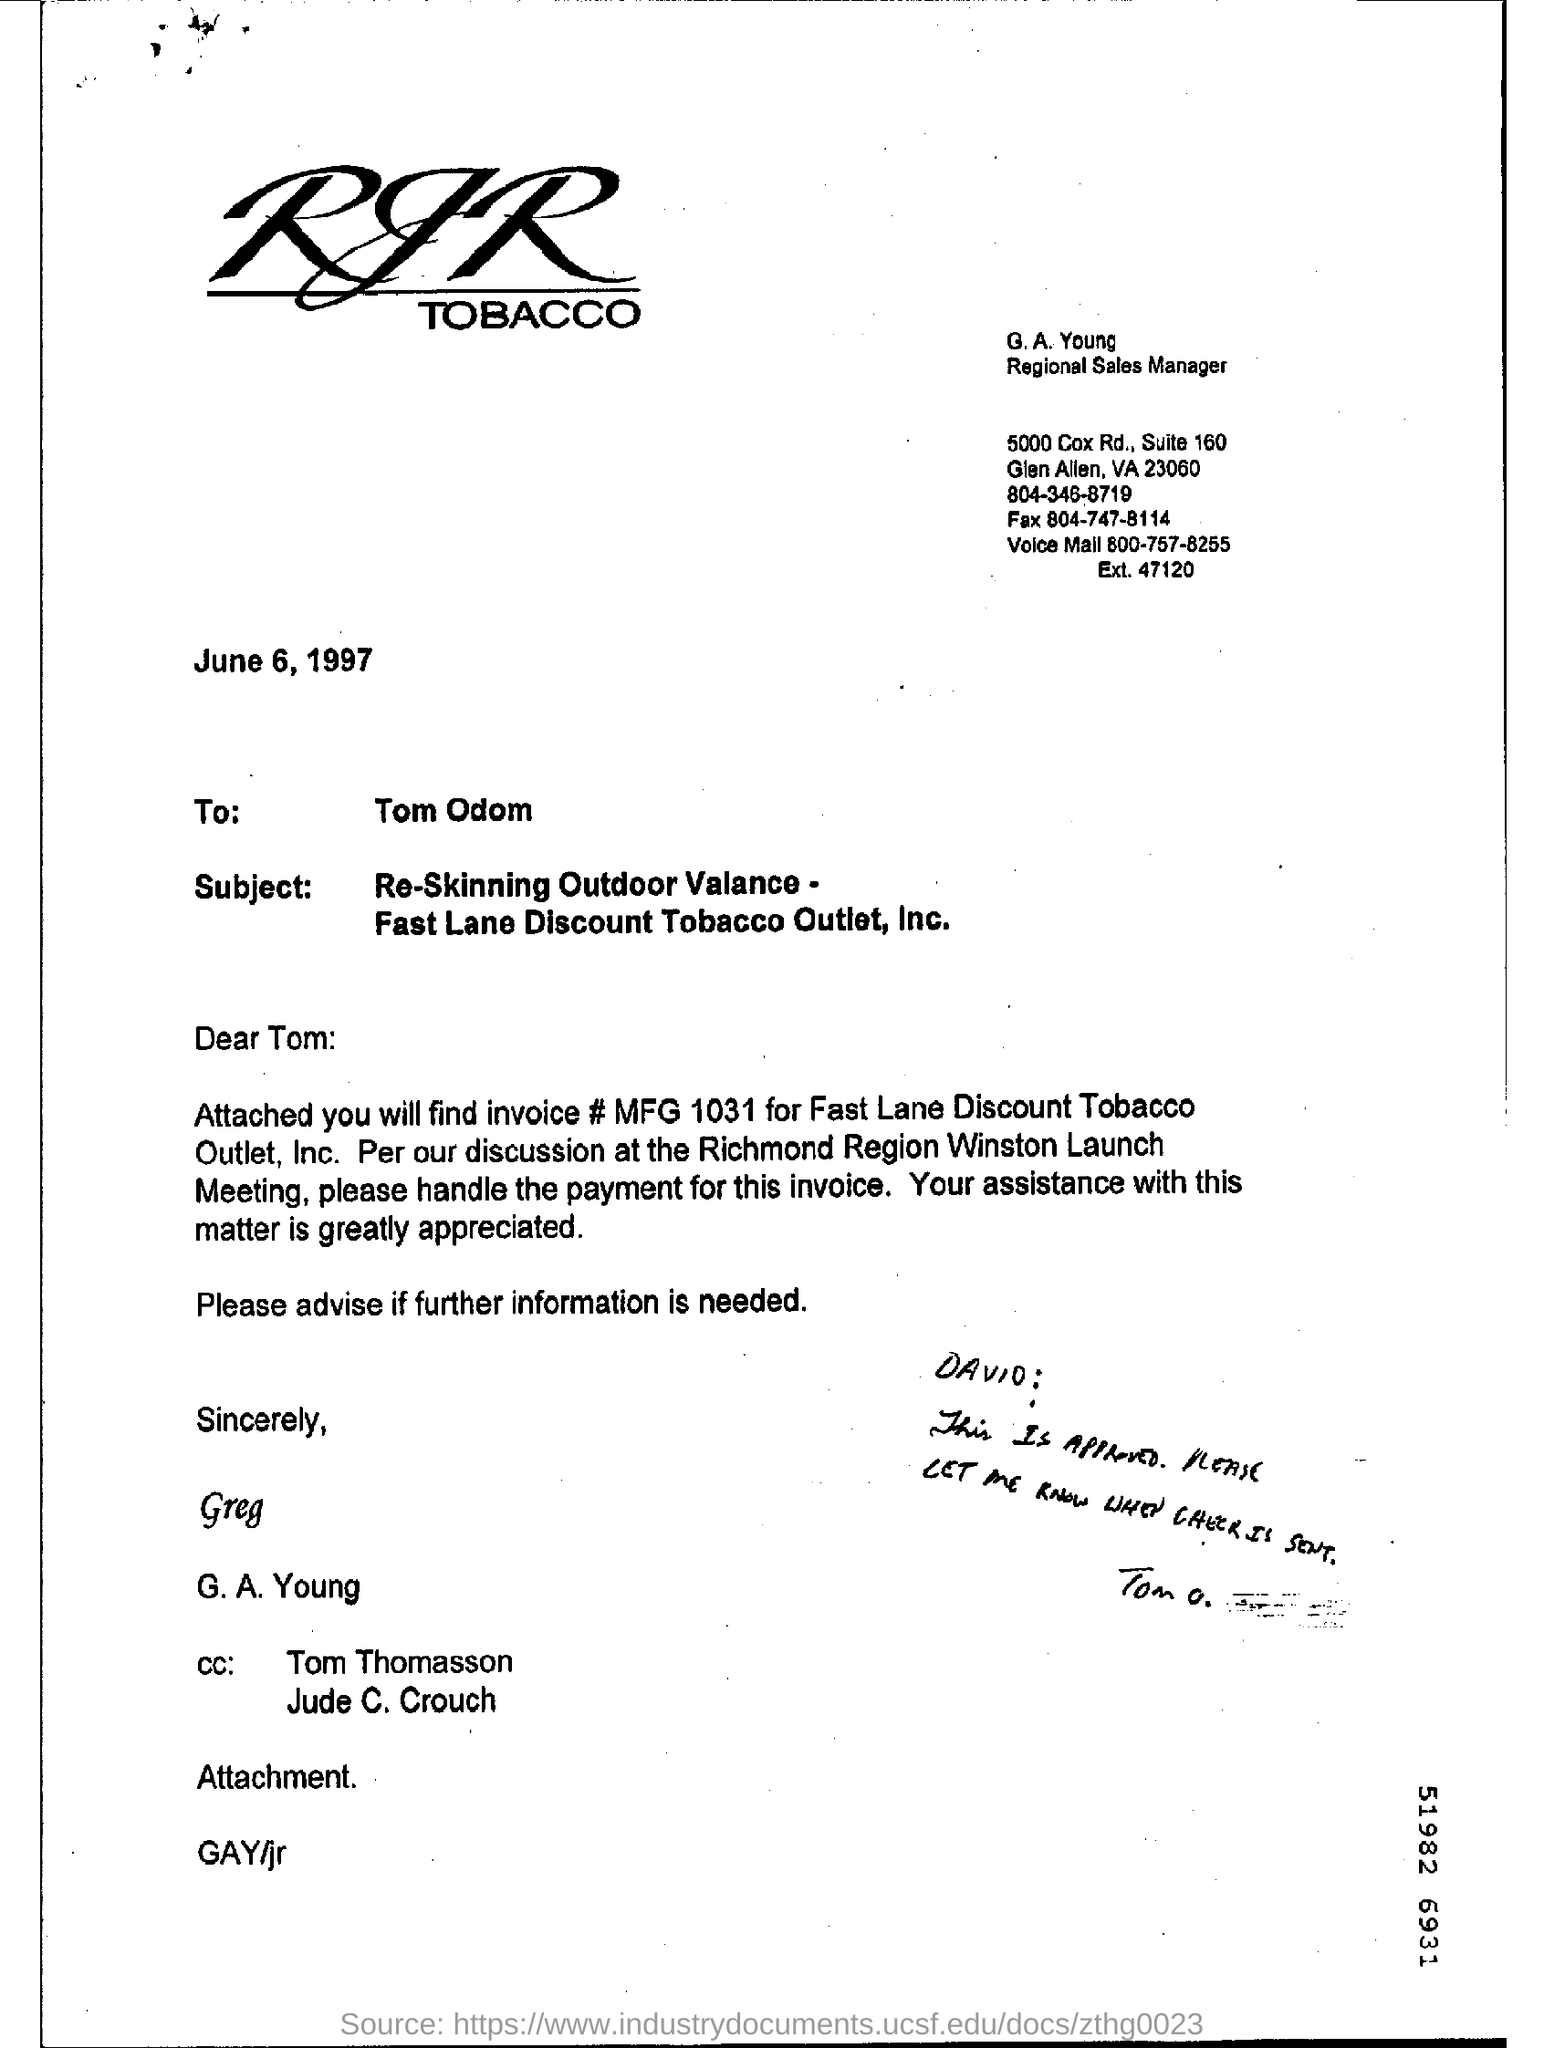Mention a couple of crucial points in this snapshot. G. A. Young is a Regional Sales Manager. The addressee of this letter is Tom Odom. The invoice number for Fast Lane Discount Tobacco Outlet, Inc. is MFG 1031. The letter is dated June 6, 1997. 